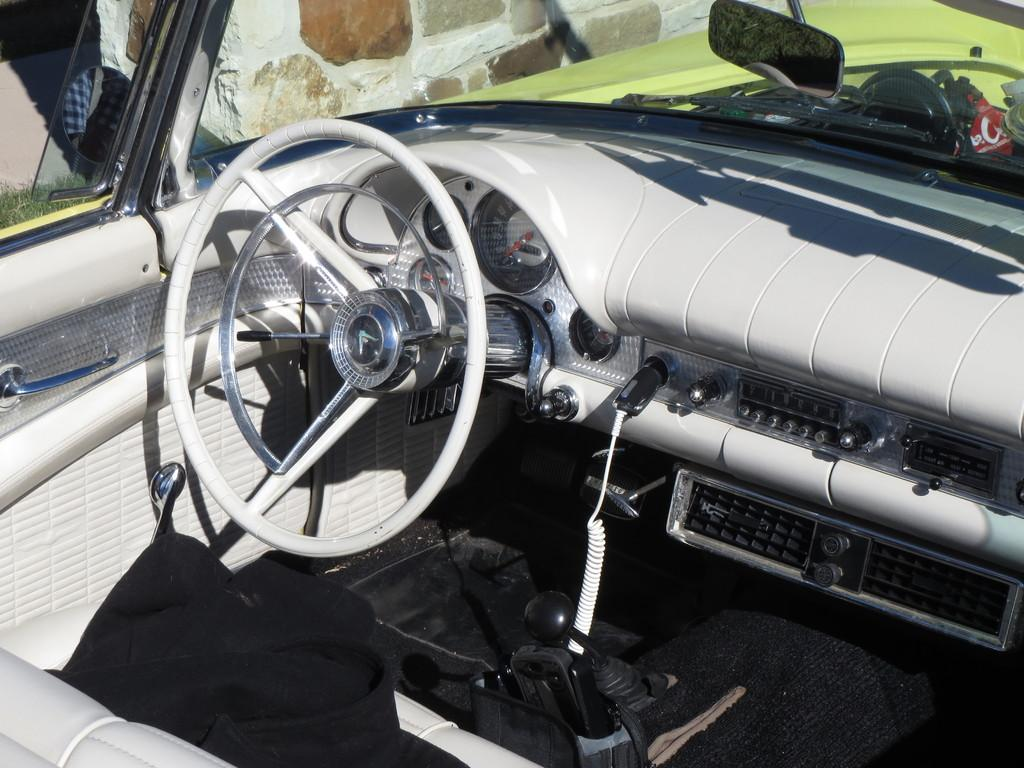What type of space is shown in the image? The image is an inside view of a vehicle. What is one of the main control devices in the vehicle? There is a steering wheel in the vehicle. What safety feature is present in the vehicle? There is a horn in the vehicle. How can the driver monitor their speed while driving? There is a speedometer in the vehicle. What mechanism allows the driver to change gears? There is a gear lever in the vehicle. How can the driver check the fuel level while driving? There is a fuel gauge in the vehicle. What instrument helps the driver monitor engine revolutions? There is a rev counter in the vehicle. How can the driver control the airflow inside the vehicle? There are air vents in the vehicle. What feature allows the driver to see what is behind the vehicle? There is a front mirror in the vehicle. How can the driver enter or exit the vehicle? There is a door in the vehicle. What type of game is being played in the vehicle in the image? There is no game being played in the vehicle in the image. What type of oil is visible in the image? There is no oil visible in the image. Is there a donkey present in the vehicle in the image? There is no donkey present in the vehicle in the image. 